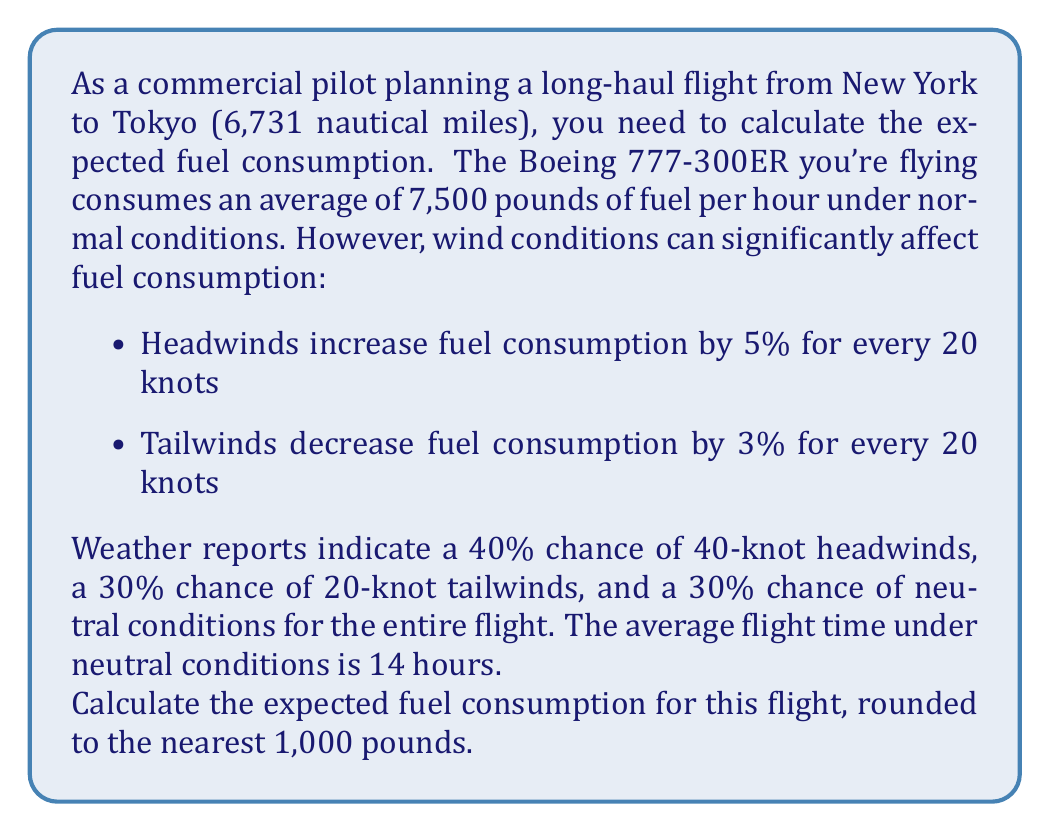What is the answer to this math problem? Let's approach this problem step-by-step:

1) First, let's calculate the base fuel consumption under neutral conditions:
   $14 \text{ hours} \times 7,500 \text{ lbs/hour} = 105,000 \text{ lbs}$

2) Now, let's calculate the fuel consumption for each wind condition:

   a) 40-knot headwinds:
      Increase: $5\% \times 2 = 10\%$ (since it's 40 knots, we double the 5% for 20 knots)
      Fuel consumption: $105,000 \times 1.10 = 115,500 \text{ lbs}$

   b) 20-knot tailwinds:
      Decrease: $3\%$
      Fuel consumption: $105,000 \times 0.97 = 101,850 \text{ lbs}$

   c) Neutral conditions:
      Fuel consumption remains $105,000 \text{ lbs}$

3) Now, let's calculate the expected value using the probability of each condition:

   $$E(\text{Fuel}) = 0.40 \times 115,500 + 0.30 \times 101,850 + 0.30 \times 105,000$$

4) Let's compute this:
   $$E(\text{Fuel}) = 46,200 + 30,555 + 31,500 = 108,255 \text{ lbs}$$

5) Rounding to the nearest 1,000 pounds:
   $108,255 \text{ lbs} \approx 108,000 \text{ lbs}$
Answer: 108,000 lbs 